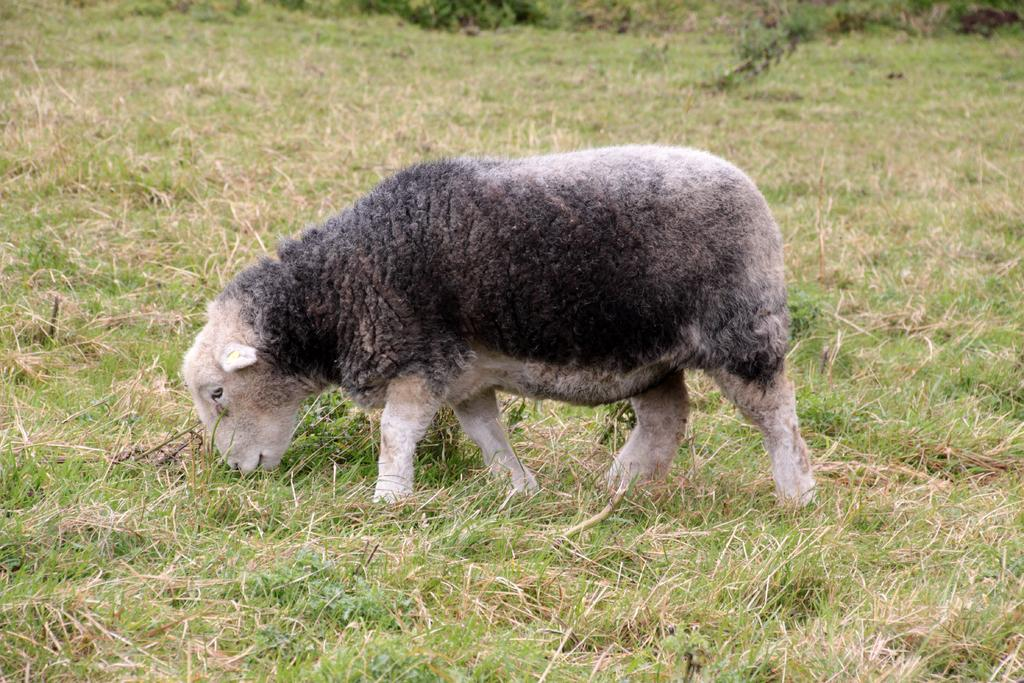What animal can be seen in the image? There is a sheep in the image. What is the sheep doing in the image? The sheep is grazing the grass. What is the sheep's opinion on the latest political developments in the image? The image does not provide any information about the sheep's thoughts or opinions, as it is focused on the sheep's physical actions. 